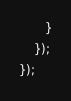Convert code to text. <code><loc_0><loc_0><loc_500><loc_500><_JavaScript_>	   }
	});
});</code> 